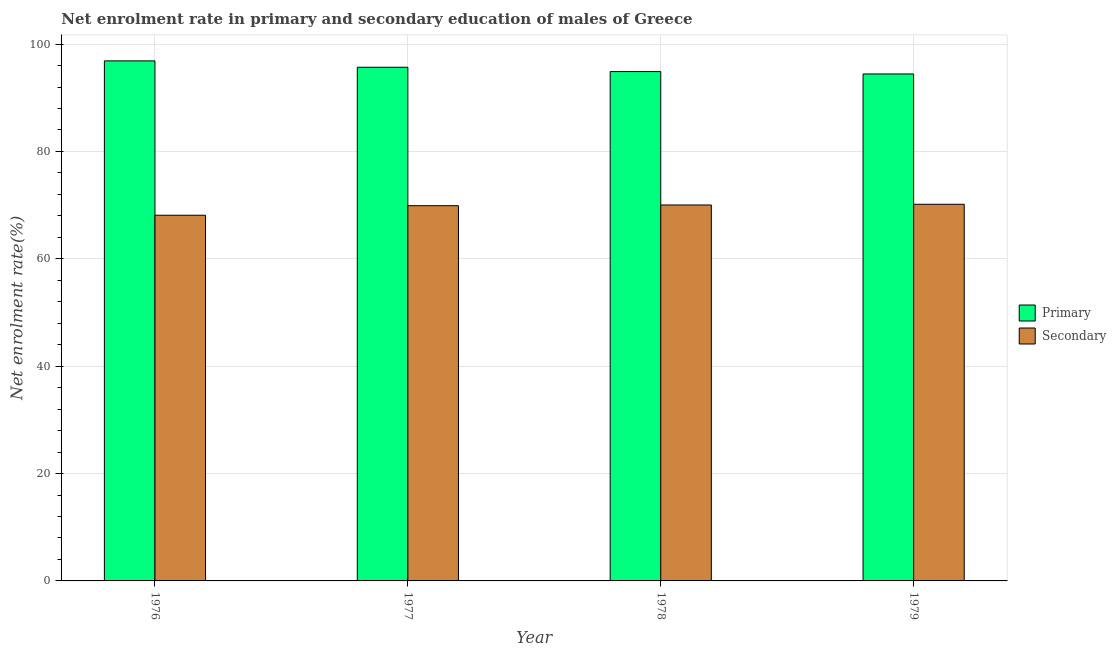How many bars are there on the 4th tick from the left?
Offer a very short reply. 2. How many bars are there on the 3rd tick from the right?
Ensure brevity in your answer.  2. What is the label of the 4th group of bars from the left?
Give a very brief answer. 1979. What is the enrollment rate in secondary education in 1977?
Provide a short and direct response. 69.9. Across all years, what is the maximum enrollment rate in secondary education?
Provide a succinct answer. 70.16. Across all years, what is the minimum enrollment rate in primary education?
Provide a succinct answer. 94.44. In which year was the enrollment rate in primary education maximum?
Offer a very short reply. 1976. In which year was the enrollment rate in primary education minimum?
Provide a short and direct response. 1979. What is the total enrollment rate in secondary education in the graph?
Your answer should be compact. 278.22. What is the difference between the enrollment rate in primary education in 1976 and that in 1978?
Give a very brief answer. 1.99. What is the difference between the enrollment rate in secondary education in 1978 and the enrollment rate in primary education in 1977?
Ensure brevity in your answer.  0.13. What is the average enrollment rate in primary education per year?
Your response must be concise. 95.47. In how many years, is the enrollment rate in secondary education greater than 56 %?
Ensure brevity in your answer.  4. What is the ratio of the enrollment rate in primary education in 1976 to that in 1977?
Provide a succinct answer. 1.01. Is the difference between the enrollment rate in secondary education in 1976 and 1979 greater than the difference between the enrollment rate in primary education in 1976 and 1979?
Offer a terse response. No. What is the difference between the highest and the second highest enrollment rate in secondary education?
Your response must be concise. 0.13. What is the difference between the highest and the lowest enrollment rate in primary education?
Offer a very short reply. 2.44. In how many years, is the enrollment rate in primary education greater than the average enrollment rate in primary education taken over all years?
Your answer should be compact. 2. Is the sum of the enrollment rate in secondary education in 1977 and 1979 greater than the maximum enrollment rate in primary education across all years?
Give a very brief answer. Yes. What does the 2nd bar from the left in 1979 represents?
Your answer should be compact. Secondary. What does the 1st bar from the right in 1978 represents?
Your response must be concise. Secondary. What is the difference between two consecutive major ticks on the Y-axis?
Your response must be concise. 20. Does the graph contain any zero values?
Offer a terse response. No. What is the title of the graph?
Provide a succinct answer. Net enrolment rate in primary and secondary education of males of Greece. Does "GDP at market prices" appear as one of the legend labels in the graph?
Your answer should be compact. No. What is the label or title of the X-axis?
Your answer should be very brief. Year. What is the label or title of the Y-axis?
Keep it short and to the point. Net enrolment rate(%). What is the Net enrolment rate(%) in Primary in 1976?
Your answer should be very brief. 96.88. What is the Net enrolment rate(%) in Secondary in 1976?
Provide a short and direct response. 68.12. What is the Net enrolment rate(%) of Primary in 1977?
Keep it short and to the point. 95.69. What is the Net enrolment rate(%) in Secondary in 1977?
Provide a succinct answer. 69.9. What is the Net enrolment rate(%) of Primary in 1978?
Offer a very short reply. 94.88. What is the Net enrolment rate(%) in Secondary in 1978?
Your response must be concise. 70.03. What is the Net enrolment rate(%) of Primary in 1979?
Ensure brevity in your answer.  94.44. What is the Net enrolment rate(%) of Secondary in 1979?
Make the answer very short. 70.16. Across all years, what is the maximum Net enrolment rate(%) of Primary?
Provide a succinct answer. 96.88. Across all years, what is the maximum Net enrolment rate(%) in Secondary?
Provide a succinct answer. 70.16. Across all years, what is the minimum Net enrolment rate(%) of Primary?
Your answer should be very brief. 94.44. Across all years, what is the minimum Net enrolment rate(%) of Secondary?
Offer a terse response. 68.12. What is the total Net enrolment rate(%) of Primary in the graph?
Offer a terse response. 381.89. What is the total Net enrolment rate(%) of Secondary in the graph?
Make the answer very short. 278.22. What is the difference between the Net enrolment rate(%) of Primary in 1976 and that in 1977?
Ensure brevity in your answer.  1.19. What is the difference between the Net enrolment rate(%) of Secondary in 1976 and that in 1977?
Your answer should be very brief. -1.78. What is the difference between the Net enrolment rate(%) of Primary in 1976 and that in 1978?
Your answer should be compact. 1.99. What is the difference between the Net enrolment rate(%) in Secondary in 1976 and that in 1978?
Your answer should be very brief. -1.91. What is the difference between the Net enrolment rate(%) of Primary in 1976 and that in 1979?
Your response must be concise. 2.44. What is the difference between the Net enrolment rate(%) of Secondary in 1976 and that in 1979?
Give a very brief answer. -2.04. What is the difference between the Net enrolment rate(%) in Primary in 1977 and that in 1978?
Give a very brief answer. 0.81. What is the difference between the Net enrolment rate(%) of Secondary in 1977 and that in 1978?
Your response must be concise. -0.13. What is the difference between the Net enrolment rate(%) of Primary in 1977 and that in 1979?
Provide a short and direct response. 1.25. What is the difference between the Net enrolment rate(%) in Secondary in 1977 and that in 1979?
Make the answer very short. -0.26. What is the difference between the Net enrolment rate(%) in Primary in 1978 and that in 1979?
Your answer should be very brief. 0.44. What is the difference between the Net enrolment rate(%) of Secondary in 1978 and that in 1979?
Your answer should be very brief. -0.13. What is the difference between the Net enrolment rate(%) in Primary in 1976 and the Net enrolment rate(%) in Secondary in 1977?
Provide a succinct answer. 26.97. What is the difference between the Net enrolment rate(%) of Primary in 1976 and the Net enrolment rate(%) of Secondary in 1978?
Make the answer very short. 26.84. What is the difference between the Net enrolment rate(%) of Primary in 1976 and the Net enrolment rate(%) of Secondary in 1979?
Your answer should be very brief. 26.71. What is the difference between the Net enrolment rate(%) in Primary in 1977 and the Net enrolment rate(%) in Secondary in 1978?
Offer a terse response. 25.66. What is the difference between the Net enrolment rate(%) of Primary in 1977 and the Net enrolment rate(%) of Secondary in 1979?
Offer a very short reply. 25.53. What is the difference between the Net enrolment rate(%) in Primary in 1978 and the Net enrolment rate(%) in Secondary in 1979?
Offer a terse response. 24.72. What is the average Net enrolment rate(%) in Primary per year?
Offer a terse response. 95.47. What is the average Net enrolment rate(%) in Secondary per year?
Offer a very short reply. 69.56. In the year 1976, what is the difference between the Net enrolment rate(%) in Primary and Net enrolment rate(%) in Secondary?
Give a very brief answer. 28.75. In the year 1977, what is the difference between the Net enrolment rate(%) of Primary and Net enrolment rate(%) of Secondary?
Make the answer very short. 25.79. In the year 1978, what is the difference between the Net enrolment rate(%) in Primary and Net enrolment rate(%) in Secondary?
Your response must be concise. 24.85. In the year 1979, what is the difference between the Net enrolment rate(%) of Primary and Net enrolment rate(%) of Secondary?
Provide a short and direct response. 24.28. What is the ratio of the Net enrolment rate(%) of Primary in 1976 to that in 1977?
Provide a short and direct response. 1.01. What is the ratio of the Net enrolment rate(%) of Secondary in 1976 to that in 1977?
Your answer should be very brief. 0.97. What is the ratio of the Net enrolment rate(%) of Primary in 1976 to that in 1978?
Your response must be concise. 1.02. What is the ratio of the Net enrolment rate(%) of Secondary in 1976 to that in 1978?
Offer a terse response. 0.97. What is the ratio of the Net enrolment rate(%) of Primary in 1976 to that in 1979?
Provide a short and direct response. 1.03. What is the ratio of the Net enrolment rate(%) of Secondary in 1976 to that in 1979?
Provide a short and direct response. 0.97. What is the ratio of the Net enrolment rate(%) in Primary in 1977 to that in 1978?
Give a very brief answer. 1.01. What is the ratio of the Net enrolment rate(%) in Secondary in 1977 to that in 1978?
Keep it short and to the point. 1. What is the ratio of the Net enrolment rate(%) in Primary in 1977 to that in 1979?
Offer a terse response. 1.01. What is the ratio of the Net enrolment rate(%) of Secondary in 1977 to that in 1979?
Give a very brief answer. 1. What is the ratio of the Net enrolment rate(%) in Primary in 1978 to that in 1979?
Make the answer very short. 1. What is the difference between the highest and the second highest Net enrolment rate(%) of Primary?
Your answer should be very brief. 1.19. What is the difference between the highest and the second highest Net enrolment rate(%) in Secondary?
Provide a short and direct response. 0.13. What is the difference between the highest and the lowest Net enrolment rate(%) in Primary?
Offer a very short reply. 2.44. What is the difference between the highest and the lowest Net enrolment rate(%) in Secondary?
Your answer should be very brief. 2.04. 